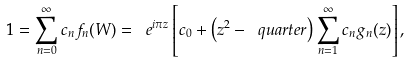<formula> <loc_0><loc_0><loc_500><loc_500>1 = \sum _ { n = 0 } ^ { \infty } c _ { n } f _ { n } ( W ) = \ e ^ { i \pi z } \left [ c _ { 0 } + \left ( z ^ { 2 } - \ q u a r t e r \right ) \sum _ { n = 1 } ^ { \infty } c _ { n } g _ { n } ( z ) \right ] ,</formula> 